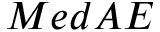<formula> <loc_0><loc_0><loc_500><loc_500>M e d A E</formula> 